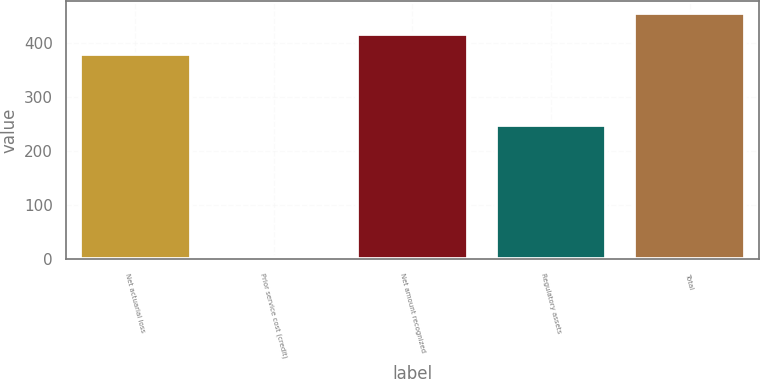Convert chart to OTSL. <chart><loc_0><loc_0><loc_500><loc_500><bar_chart><fcel>Net actuarial loss<fcel>Prior service cost (credit)<fcel>Net amount recognized<fcel>Regulatory assets<fcel>Total<nl><fcel>379<fcel>4<fcel>416.9<fcel>248<fcel>454.8<nl></chart> 